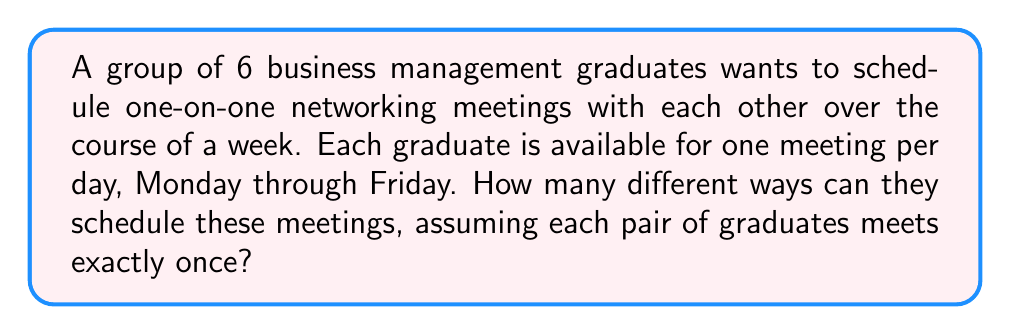What is the answer to this math problem? Let's approach this step-by-step:

1) First, we need to determine how many meetings will take place. With 6 graduates, each needs to meet with 5 others. The total number of meetings is:

   $$(6 \times 5) / 2 = 15$$ meetings

2) Now, we need to distribute these 15 meetings over 5 days. This is equivalent to distributing 15 distinct objects (meetings) into 5 distinct boxes (days). We can use the multiplication principle here.

3) For the first day, we have $\binom{15}{3} = 455$ ways to choose 3 meetings.

4) For the second day, we have $\binom{12}{3} = 220$ ways to choose 3 meetings from the remaining 12.

5) For the third day, we have $\binom{9}{3} = 84$ ways to choose 3 meetings from the remaining 9.

6) For the fourth day, we have $\binom{6}{3} = 20$ ways to choose 3 meetings from the remaining 6.

7) The last 3 meetings must be scheduled on the fifth day.

8) By the multiplication principle, the total number of ways to schedule the meetings is:

   $$455 \times 220 \times 84 \times 20 \times 1 = 168,168,000$$

Therefore, there are 168,168,000 different ways to schedule these networking meetings.
Answer: 168,168,000 